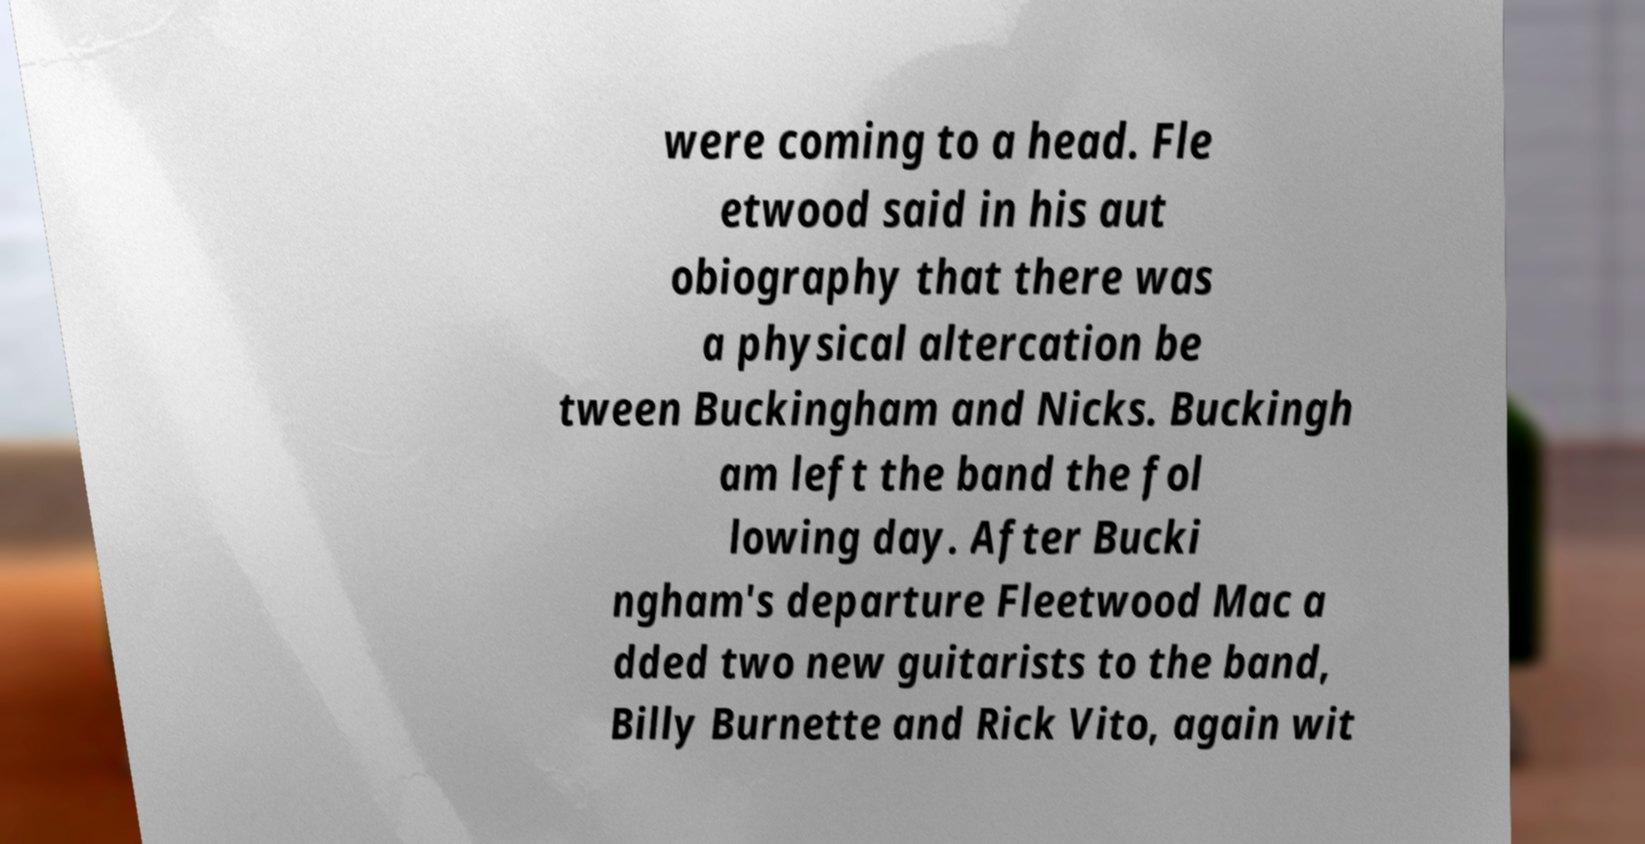What messages or text are displayed in this image? I need them in a readable, typed format. were coming to a head. Fle etwood said in his aut obiography that there was a physical altercation be tween Buckingham and Nicks. Buckingh am left the band the fol lowing day. After Bucki ngham's departure Fleetwood Mac a dded two new guitarists to the band, Billy Burnette and Rick Vito, again wit 